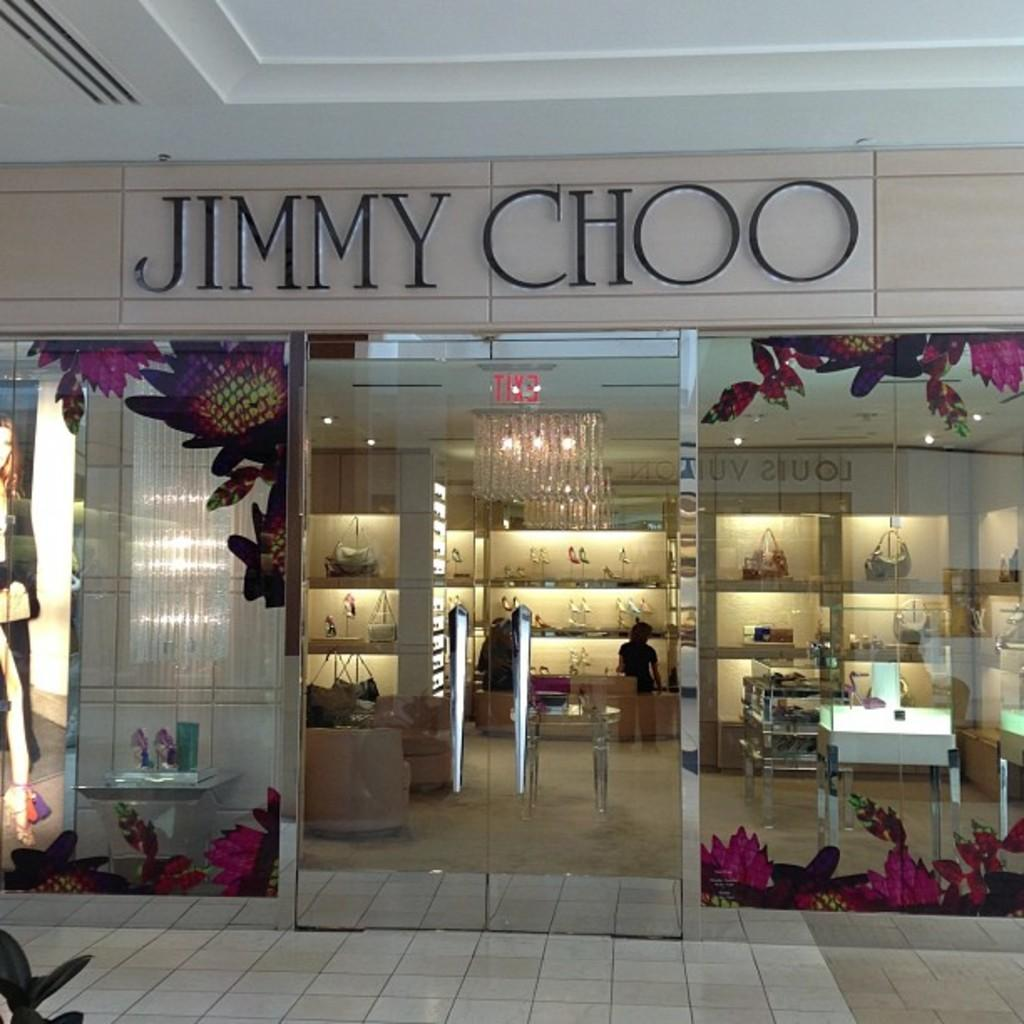What type of surface is visible in the image? There is a pavement in the image. What can be seen in the background of the image? There is a shop in the background of the image. What type of walls are present in the image? There are glass walls in the image. What type of items are visible in the image? There is footwear and bags visible in the image. What is visible at the top of the image? There is a ceiling visible at the top of the image. What is the name of the person who owns the spade in the image? There is no spade present in the image, so it is not possible to determine the name of the owner. 